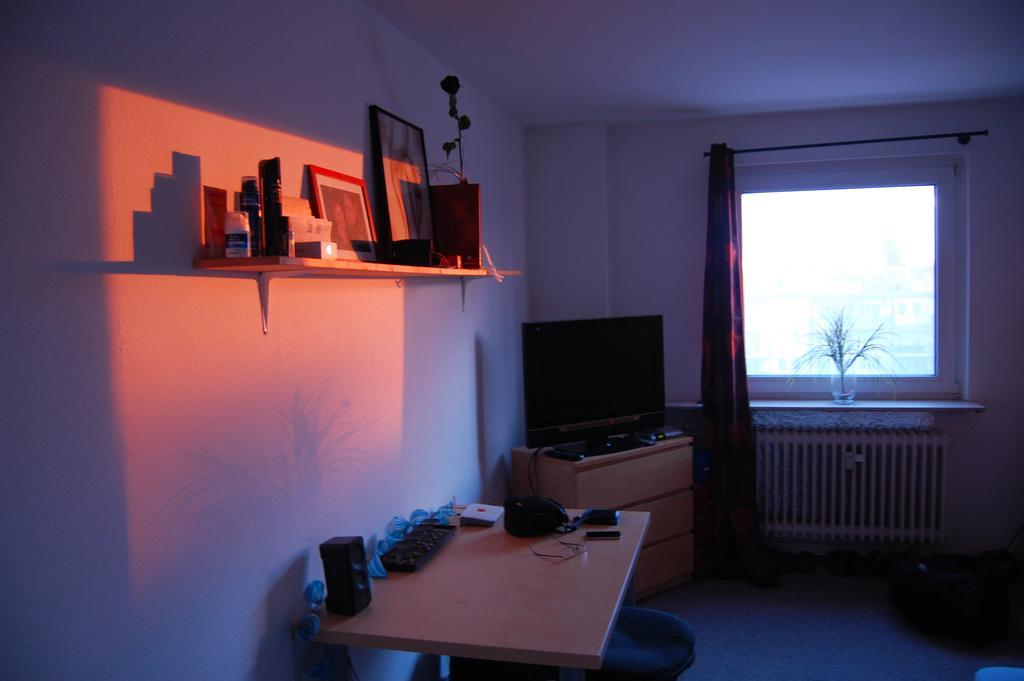Please provide a concise description of this image. In a room there are objects on a table, there is a window, curtain and a plant. At the back there is a monitor. There is a shelf on which there are photo frames and other objects. 